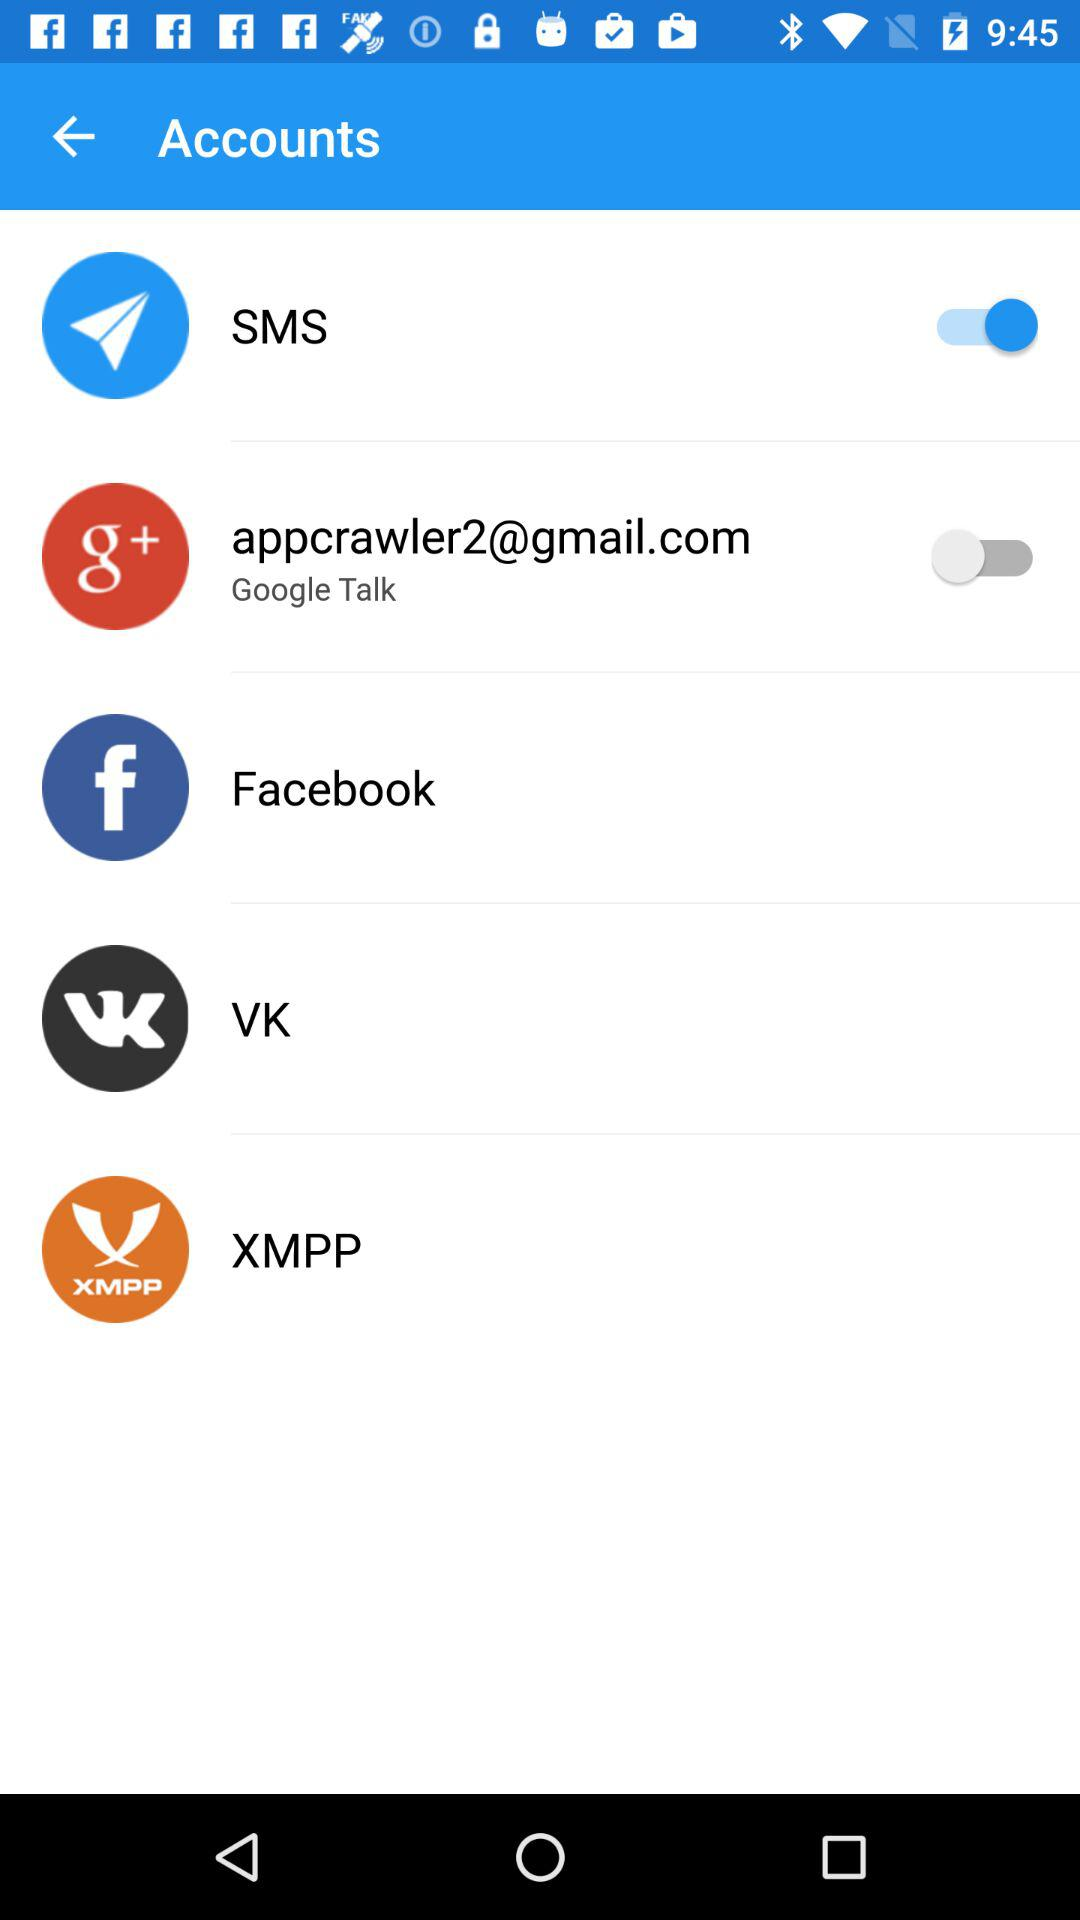What is the email address of the Google Talk account? The email address is appcrawler2@gmail.com. 